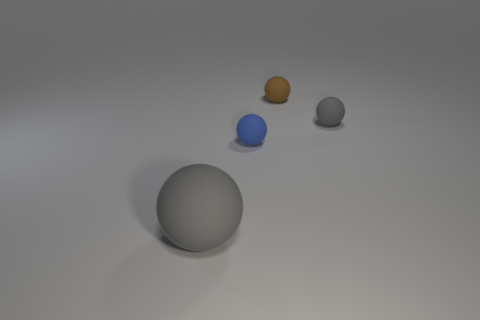How many tiny blue balls are to the right of the tiny matte ball that is on the left side of the small brown thing?
Make the answer very short. 0. The thing that is the same color as the large ball is what size?
Offer a terse response. Small. What number of things are brown spheres or rubber balls on the right side of the tiny blue thing?
Your response must be concise. 2. Are there any balls made of the same material as the blue object?
Ensure brevity in your answer.  Yes. How many gray things are on the right side of the big gray matte sphere and in front of the small blue sphere?
Give a very brief answer. 0. There is a gray thing to the left of the tiny blue rubber object; what material is it?
Offer a very short reply. Rubber. What size is the gray thing that is the same material as the tiny gray sphere?
Ensure brevity in your answer.  Large. Are there any gray things behind the large gray rubber ball?
Give a very brief answer. Yes. There is another gray matte object that is the same shape as the small gray object; what size is it?
Keep it short and to the point. Large. There is a big rubber ball; does it have the same color as the matte sphere on the right side of the tiny brown matte thing?
Keep it short and to the point. Yes. 